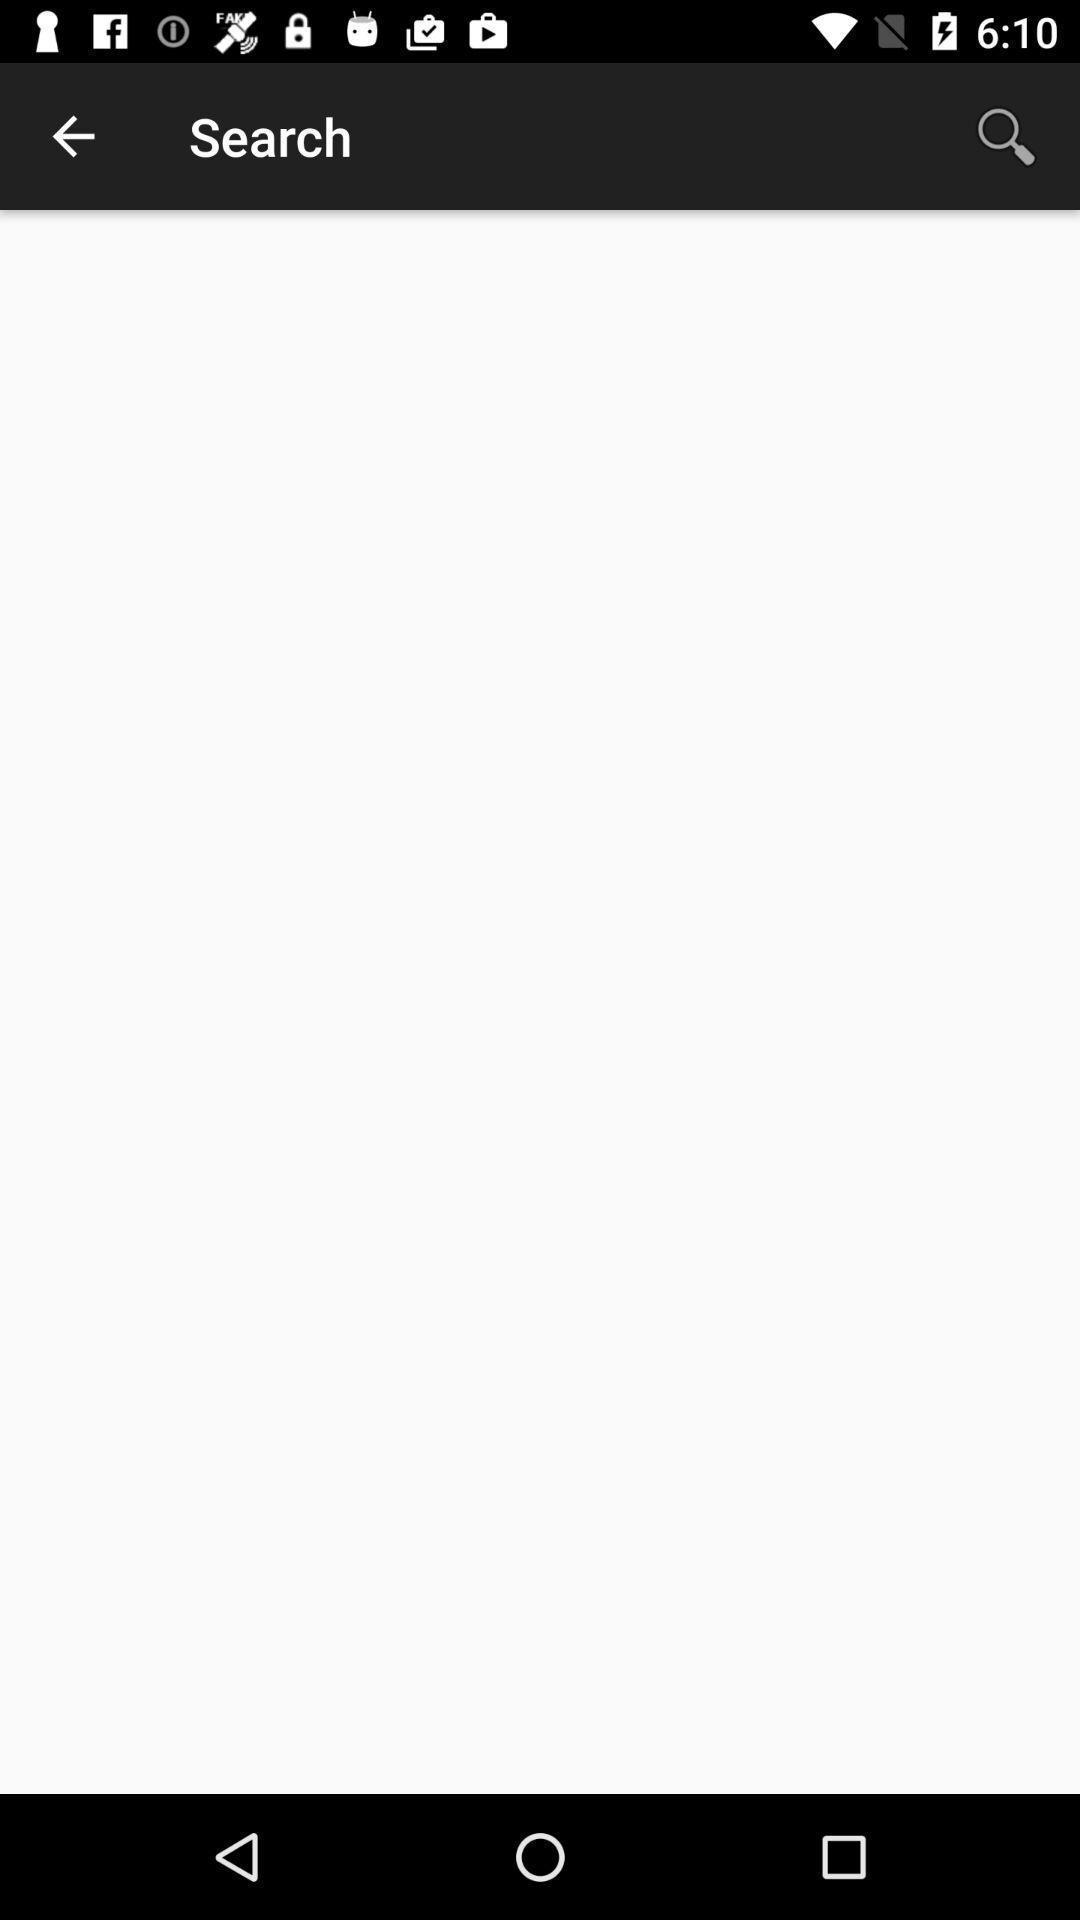What can you discern from this picture? Search page displayed with a search bar. 